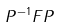<formula> <loc_0><loc_0><loc_500><loc_500>P ^ { - 1 } F P</formula> 